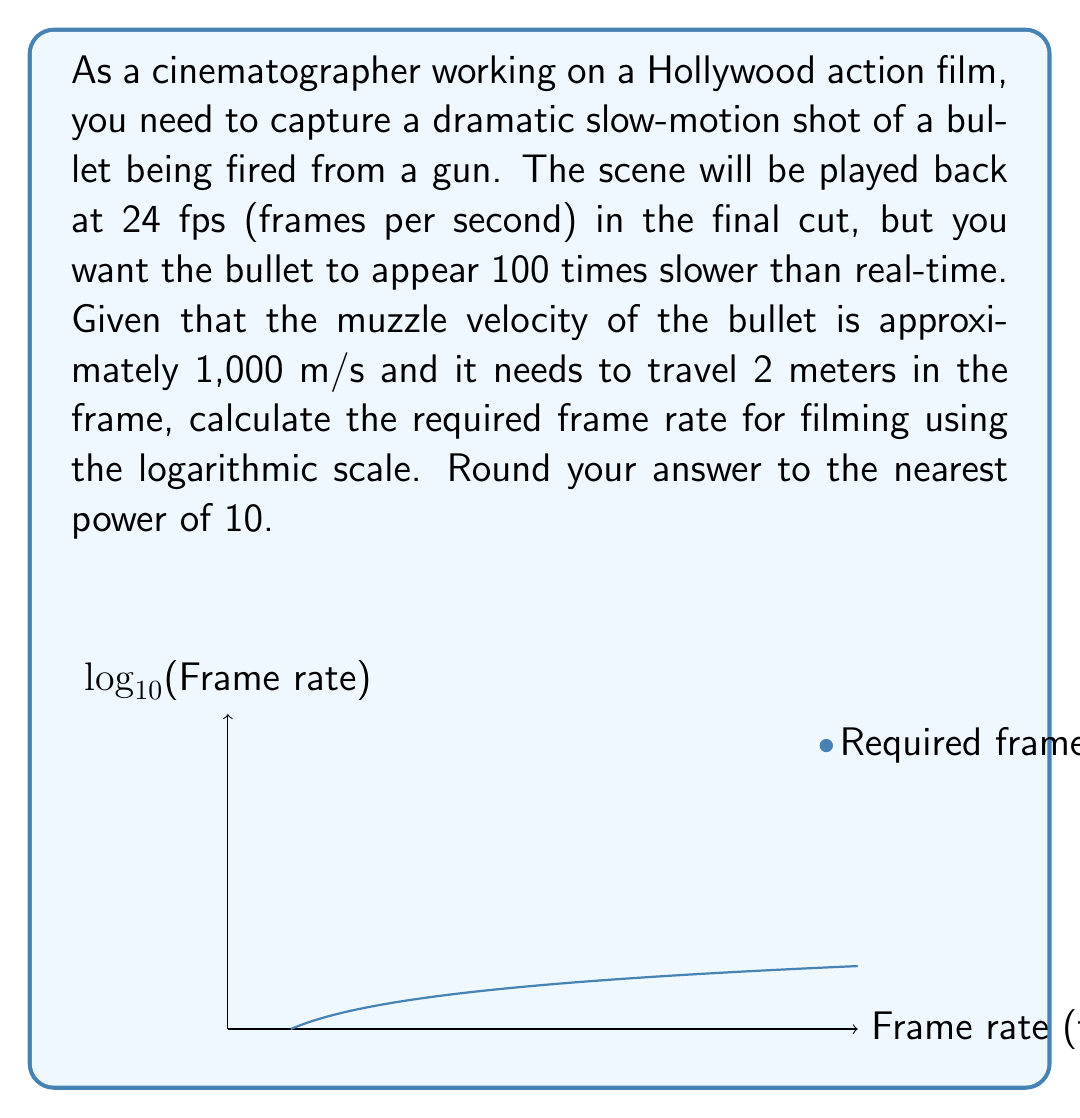Could you help me with this problem? Let's approach this step-by-step:

1) First, we need to calculate the time it takes for the bullet to travel 2 meters in real-time:
   $t = \frac{distance}{velocity} = \frac{2 \text{ m}}{1000 \text{ m/s}} = 0.002 \text{ s}$

2) We want this 0.002 seconds to appear as 100 times slower, so in the final cut, it should last:
   $0.002 \text{ s} \times 100 = 0.2 \text{ s}$

3) The final cut will be played at 24 fps, so we need to calculate how many frames this 0.2 seconds will occupy:
   $0.2 \text{ s} \times 24 \text{ fps} = 4.8 \text{ frames}$

4) Now, to calculate the required frame rate for filming, we need to capture these 4.8 frames in the original 0.002 seconds:
   $\text{Required frame rate} = \frac{4.8 \text{ frames}}{0.002 \text{ s}} = 2400 \text{ fps}$

5) To express this on a logarithmic scale, we use $\log_{10}$:
   $\log_{10}(2400) \approx 3.38$

6) Rounding to the nearest power of 10, we get:
   $10^3 = 1000 \text{ fps}$

Therefore, the required frame rate for filming, rounded to the nearest power of 10 on a logarithmic scale, is 1000 fps.
Answer: $10^3 \text{ fps}$ 